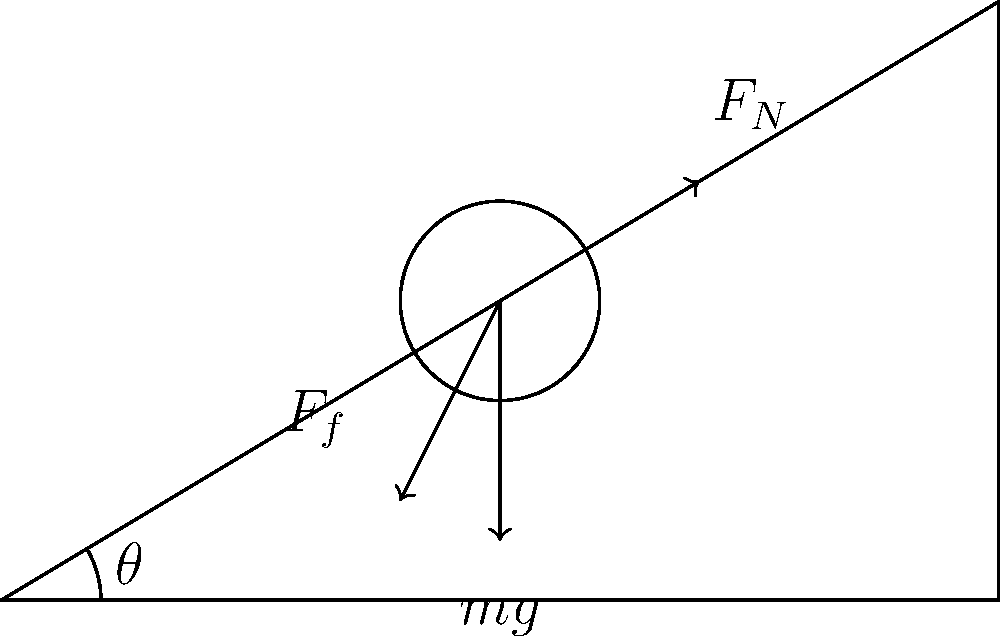A patient weighing 80 kg is placed on a hospital bed inclined at an angle $\theta = 30^\circ$ to the horizontal. The coefficient of static friction between the patient and the bed is $\mu_s = 0.4$. What is the minimum force parallel to the bed surface that a nurse must apply to prevent the patient from sliding down the bed? Let's approach this problem step-by-step:

1) First, we need to identify the forces acting on the patient:
   - Weight ($mg$) acting downward
   - Normal force ($F_N$) perpendicular to the bed surface
   - Friction force ($F_f$) parallel to the bed surface, opposing motion
   - The force applied by the nurse ($F$), which we need to calculate

2) We can break down the weight into components parallel and perpendicular to the bed:
   - Parallel component: $mg \sin \theta$
   - Perpendicular component: $mg \cos \theta$

3) The normal force is equal to the perpendicular component of weight:
   $F_N = mg \cos \theta$

4) The maximum static friction force is given by:
   $F_f = \mu_s F_N = \mu_s mg \cos \theta$

5) For the patient to be on the verge of sliding, the sum of forces parallel to the bed must be zero:
   $F + F_f = mg \sin \theta$

6) Substituting the expression for $F_f$:
   $F + \mu_s mg \cos \theta = mg \sin \theta$

7) Solving for $F$:
   $F = mg \sin \theta - \mu_s mg \cos \theta$
   $F = mg (\sin \theta - \mu_s \cos \theta)$

8) Now, let's plug in the values:
   $m = 80$ kg
   $g = 9.8$ m/s²
   $\theta = 30^\circ$
   $\mu_s = 0.4$

   $F = 80 \cdot 9.8 \cdot (\sin 30^\circ - 0.4 \cos 30^\circ)$
   $F = 784 \cdot (0.5 - 0.4 \cdot 0.866)$
   $F = 784 \cdot 0.1536$
   $F \approx 120.4$ N

Therefore, the nurse must apply a force of approximately 120.4 N parallel to the bed surface to prevent the patient from sliding.
Answer: 120.4 N 